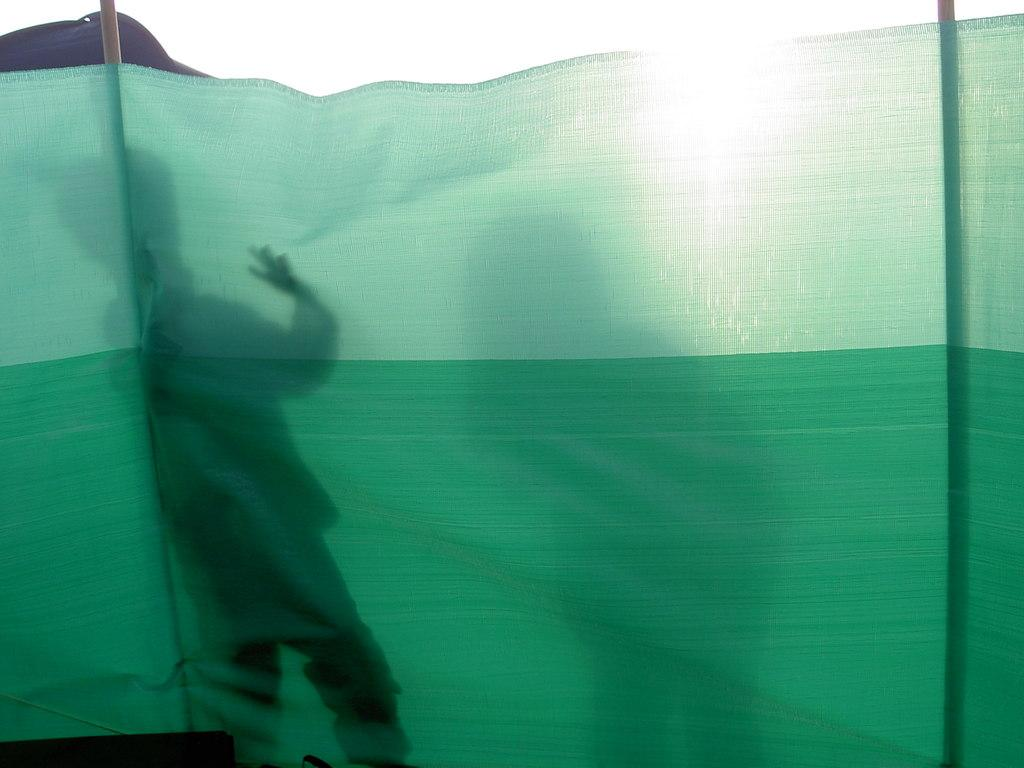What color is the cloth that is visible in the image? There is a green color cloth in the image. What else can be observed in the image besides the cloth? Shadows are visible in the image. What historical event is taking place in the image? There is no historical event depicted in the image; it only shows a green color cloth and shadows. Can you see any church in the image? There is no church present in the image. 